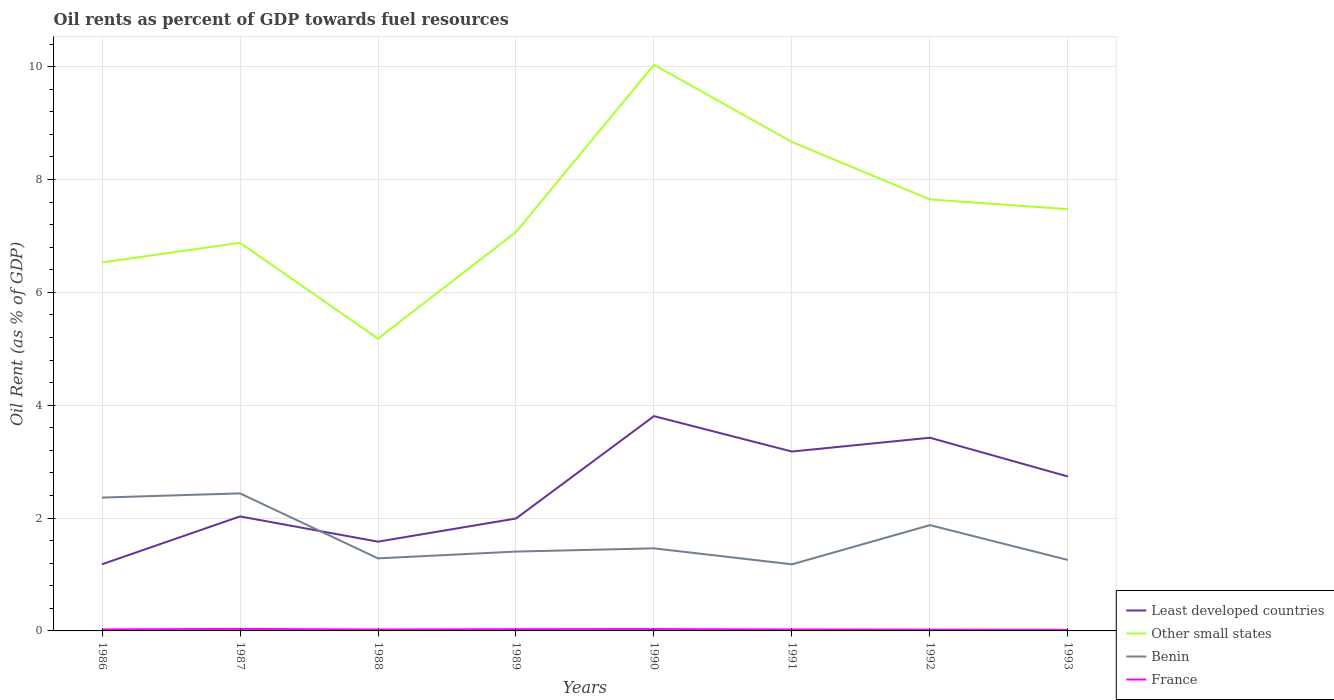How many different coloured lines are there?
Keep it short and to the point. 4. Does the line corresponding to Benin intersect with the line corresponding to France?
Give a very brief answer. No. Across all years, what is the maximum oil rent in France?
Give a very brief answer. 0.02. What is the total oil rent in Least developed countries in the graph?
Make the answer very short. -0.71. What is the difference between the highest and the second highest oil rent in Other small states?
Your answer should be very brief. 4.85. Does the graph contain any zero values?
Offer a terse response. No. How are the legend labels stacked?
Offer a terse response. Vertical. What is the title of the graph?
Offer a very short reply. Oil rents as percent of GDP towards fuel resources. What is the label or title of the Y-axis?
Your answer should be compact. Oil Rent (as % of GDP). What is the Oil Rent (as % of GDP) in Least developed countries in 1986?
Keep it short and to the point. 1.18. What is the Oil Rent (as % of GDP) in Other small states in 1986?
Offer a very short reply. 6.53. What is the Oil Rent (as % of GDP) of Benin in 1986?
Your answer should be compact. 2.36. What is the Oil Rent (as % of GDP) of France in 1986?
Make the answer very short. 0.03. What is the Oil Rent (as % of GDP) in Least developed countries in 1987?
Your answer should be very brief. 2.03. What is the Oil Rent (as % of GDP) of Other small states in 1987?
Make the answer very short. 6.88. What is the Oil Rent (as % of GDP) of Benin in 1987?
Make the answer very short. 2.44. What is the Oil Rent (as % of GDP) in France in 1987?
Make the answer very short. 0.04. What is the Oil Rent (as % of GDP) in Least developed countries in 1988?
Give a very brief answer. 1.58. What is the Oil Rent (as % of GDP) in Other small states in 1988?
Offer a terse response. 5.18. What is the Oil Rent (as % of GDP) of Benin in 1988?
Ensure brevity in your answer.  1.29. What is the Oil Rent (as % of GDP) of France in 1988?
Keep it short and to the point. 0.02. What is the Oil Rent (as % of GDP) of Least developed countries in 1989?
Offer a terse response. 1.99. What is the Oil Rent (as % of GDP) of Other small states in 1989?
Offer a terse response. 7.07. What is the Oil Rent (as % of GDP) of Benin in 1989?
Your answer should be very brief. 1.41. What is the Oil Rent (as % of GDP) in France in 1989?
Offer a terse response. 0.03. What is the Oil Rent (as % of GDP) of Least developed countries in 1990?
Your answer should be very brief. 3.81. What is the Oil Rent (as % of GDP) in Other small states in 1990?
Make the answer very short. 10.03. What is the Oil Rent (as % of GDP) in Benin in 1990?
Your answer should be very brief. 1.46. What is the Oil Rent (as % of GDP) of France in 1990?
Provide a succinct answer. 0.03. What is the Oil Rent (as % of GDP) in Least developed countries in 1991?
Provide a short and direct response. 3.18. What is the Oil Rent (as % of GDP) of Other small states in 1991?
Your response must be concise. 8.66. What is the Oil Rent (as % of GDP) of Benin in 1991?
Make the answer very short. 1.18. What is the Oil Rent (as % of GDP) in France in 1991?
Your answer should be compact. 0.03. What is the Oil Rent (as % of GDP) in Least developed countries in 1992?
Ensure brevity in your answer.  3.42. What is the Oil Rent (as % of GDP) in Other small states in 1992?
Offer a very short reply. 7.65. What is the Oil Rent (as % of GDP) in Benin in 1992?
Your answer should be very brief. 1.87. What is the Oil Rent (as % of GDP) of France in 1992?
Ensure brevity in your answer.  0.02. What is the Oil Rent (as % of GDP) of Least developed countries in 1993?
Your answer should be compact. 2.74. What is the Oil Rent (as % of GDP) of Other small states in 1993?
Your answer should be very brief. 7.47. What is the Oil Rent (as % of GDP) of Benin in 1993?
Ensure brevity in your answer.  1.26. What is the Oil Rent (as % of GDP) in France in 1993?
Make the answer very short. 0.02. Across all years, what is the maximum Oil Rent (as % of GDP) of Least developed countries?
Provide a short and direct response. 3.81. Across all years, what is the maximum Oil Rent (as % of GDP) of Other small states?
Your response must be concise. 10.03. Across all years, what is the maximum Oil Rent (as % of GDP) of Benin?
Give a very brief answer. 2.44. Across all years, what is the maximum Oil Rent (as % of GDP) in France?
Your response must be concise. 0.04. Across all years, what is the minimum Oil Rent (as % of GDP) of Least developed countries?
Offer a very short reply. 1.18. Across all years, what is the minimum Oil Rent (as % of GDP) of Other small states?
Offer a terse response. 5.18. Across all years, what is the minimum Oil Rent (as % of GDP) in Benin?
Your answer should be very brief. 1.18. Across all years, what is the minimum Oil Rent (as % of GDP) of France?
Offer a very short reply. 0.02. What is the total Oil Rent (as % of GDP) in Least developed countries in the graph?
Your response must be concise. 19.93. What is the total Oil Rent (as % of GDP) in Other small states in the graph?
Keep it short and to the point. 59.47. What is the total Oil Rent (as % of GDP) in Benin in the graph?
Provide a short and direct response. 13.27. What is the total Oil Rent (as % of GDP) in France in the graph?
Offer a terse response. 0.22. What is the difference between the Oil Rent (as % of GDP) in Least developed countries in 1986 and that in 1987?
Make the answer very short. -0.85. What is the difference between the Oil Rent (as % of GDP) of Other small states in 1986 and that in 1987?
Provide a succinct answer. -0.35. What is the difference between the Oil Rent (as % of GDP) in Benin in 1986 and that in 1987?
Your answer should be compact. -0.07. What is the difference between the Oil Rent (as % of GDP) in France in 1986 and that in 1987?
Offer a terse response. -0.01. What is the difference between the Oil Rent (as % of GDP) in Least developed countries in 1986 and that in 1988?
Keep it short and to the point. -0.4. What is the difference between the Oil Rent (as % of GDP) of Other small states in 1986 and that in 1988?
Provide a short and direct response. 1.35. What is the difference between the Oil Rent (as % of GDP) in Benin in 1986 and that in 1988?
Give a very brief answer. 1.08. What is the difference between the Oil Rent (as % of GDP) of France in 1986 and that in 1988?
Ensure brevity in your answer.  0. What is the difference between the Oil Rent (as % of GDP) in Least developed countries in 1986 and that in 1989?
Give a very brief answer. -0.81. What is the difference between the Oil Rent (as % of GDP) in Other small states in 1986 and that in 1989?
Give a very brief answer. -0.54. What is the difference between the Oil Rent (as % of GDP) of Benin in 1986 and that in 1989?
Your answer should be compact. 0.96. What is the difference between the Oil Rent (as % of GDP) of France in 1986 and that in 1989?
Offer a very short reply. -0. What is the difference between the Oil Rent (as % of GDP) of Least developed countries in 1986 and that in 1990?
Your answer should be compact. -2.63. What is the difference between the Oil Rent (as % of GDP) of Other small states in 1986 and that in 1990?
Give a very brief answer. -3.5. What is the difference between the Oil Rent (as % of GDP) in Benin in 1986 and that in 1990?
Your answer should be very brief. 0.9. What is the difference between the Oil Rent (as % of GDP) in France in 1986 and that in 1990?
Your answer should be compact. -0.01. What is the difference between the Oil Rent (as % of GDP) of Least developed countries in 1986 and that in 1991?
Give a very brief answer. -2. What is the difference between the Oil Rent (as % of GDP) of Other small states in 1986 and that in 1991?
Make the answer very short. -2.13. What is the difference between the Oil Rent (as % of GDP) of Benin in 1986 and that in 1991?
Keep it short and to the point. 1.18. What is the difference between the Oil Rent (as % of GDP) of France in 1986 and that in 1991?
Offer a terse response. 0. What is the difference between the Oil Rent (as % of GDP) in Least developed countries in 1986 and that in 1992?
Provide a short and direct response. -2.24. What is the difference between the Oil Rent (as % of GDP) in Other small states in 1986 and that in 1992?
Your answer should be very brief. -1.12. What is the difference between the Oil Rent (as % of GDP) in Benin in 1986 and that in 1992?
Provide a succinct answer. 0.49. What is the difference between the Oil Rent (as % of GDP) in France in 1986 and that in 1992?
Offer a very short reply. 0.01. What is the difference between the Oil Rent (as % of GDP) of Least developed countries in 1986 and that in 1993?
Make the answer very short. -1.55. What is the difference between the Oil Rent (as % of GDP) of Other small states in 1986 and that in 1993?
Ensure brevity in your answer.  -0.94. What is the difference between the Oil Rent (as % of GDP) in Benin in 1986 and that in 1993?
Offer a very short reply. 1.11. What is the difference between the Oil Rent (as % of GDP) in France in 1986 and that in 1993?
Offer a very short reply. 0.01. What is the difference between the Oil Rent (as % of GDP) in Least developed countries in 1987 and that in 1988?
Make the answer very short. 0.45. What is the difference between the Oil Rent (as % of GDP) in Other small states in 1987 and that in 1988?
Keep it short and to the point. 1.7. What is the difference between the Oil Rent (as % of GDP) in Benin in 1987 and that in 1988?
Your answer should be compact. 1.15. What is the difference between the Oil Rent (as % of GDP) in France in 1987 and that in 1988?
Make the answer very short. 0.01. What is the difference between the Oil Rent (as % of GDP) of Least developed countries in 1987 and that in 1989?
Offer a terse response. 0.04. What is the difference between the Oil Rent (as % of GDP) in Other small states in 1987 and that in 1989?
Offer a very short reply. -0.19. What is the difference between the Oil Rent (as % of GDP) in Benin in 1987 and that in 1989?
Make the answer very short. 1.03. What is the difference between the Oil Rent (as % of GDP) of France in 1987 and that in 1989?
Give a very brief answer. 0. What is the difference between the Oil Rent (as % of GDP) of Least developed countries in 1987 and that in 1990?
Keep it short and to the point. -1.78. What is the difference between the Oil Rent (as % of GDP) of Other small states in 1987 and that in 1990?
Give a very brief answer. -3.15. What is the difference between the Oil Rent (as % of GDP) of Benin in 1987 and that in 1990?
Offer a terse response. 0.97. What is the difference between the Oil Rent (as % of GDP) of France in 1987 and that in 1990?
Keep it short and to the point. 0. What is the difference between the Oil Rent (as % of GDP) in Least developed countries in 1987 and that in 1991?
Your response must be concise. -1.15. What is the difference between the Oil Rent (as % of GDP) in Other small states in 1987 and that in 1991?
Provide a succinct answer. -1.79. What is the difference between the Oil Rent (as % of GDP) in Benin in 1987 and that in 1991?
Provide a short and direct response. 1.26. What is the difference between the Oil Rent (as % of GDP) in France in 1987 and that in 1991?
Keep it short and to the point. 0.01. What is the difference between the Oil Rent (as % of GDP) of Least developed countries in 1987 and that in 1992?
Offer a very short reply. -1.39. What is the difference between the Oil Rent (as % of GDP) in Other small states in 1987 and that in 1992?
Your answer should be compact. -0.77. What is the difference between the Oil Rent (as % of GDP) of Benin in 1987 and that in 1992?
Offer a terse response. 0.56. What is the difference between the Oil Rent (as % of GDP) of France in 1987 and that in 1992?
Give a very brief answer. 0.01. What is the difference between the Oil Rent (as % of GDP) of Least developed countries in 1987 and that in 1993?
Keep it short and to the point. -0.71. What is the difference between the Oil Rent (as % of GDP) in Other small states in 1987 and that in 1993?
Your response must be concise. -0.6. What is the difference between the Oil Rent (as % of GDP) in Benin in 1987 and that in 1993?
Offer a terse response. 1.18. What is the difference between the Oil Rent (as % of GDP) of France in 1987 and that in 1993?
Give a very brief answer. 0.02. What is the difference between the Oil Rent (as % of GDP) of Least developed countries in 1988 and that in 1989?
Provide a succinct answer. -0.41. What is the difference between the Oil Rent (as % of GDP) in Other small states in 1988 and that in 1989?
Provide a succinct answer. -1.89. What is the difference between the Oil Rent (as % of GDP) in Benin in 1988 and that in 1989?
Ensure brevity in your answer.  -0.12. What is the difference between the Oil Rent (as % of GDP) in France in 1988 and that in 1989?
Offer a very short reply. -0.01. What is the difference between the Oil Rent (as % of GDP) in Least developed countries in 1988 and that in 1990?
Ensure brevity in your answer.  -2.22. What is the difference between the Oil Rent (as % of GDP) in Other small states in 1988 and that in 1990?
Your response must be concise. -4.85. What is the difference between the Oil Rent (as % of GDP) in Benin in 1988 and that in 1990?
Provide a succinct answer. -0.18. What is the difference between the Oil Rent (as % of GDP) of France in 1988 and that in 1990?
Your answer should be compact. -0.01. What is the difference between the Oil Rent (as % of GDP) of Least developed countries in 1988 and that in 1991?
Keep it short and to the point. -1.6. What is the difference between the Oil Rent (as % of GDP) of Other small states in 1988 and that in 1991?
Offer a terse response. -3.48. What is the difference between the Oil Rent (as % of GDP) of Benin in 1988 and that in 1991?
Your answer should be compact. 0.11. What is the difference between the Oil Rent (as % of GDP) in France in 1988 and that in 1991?
Your response must be concise. -0. What is the difference between the Oil Rent (as % of GDP) of Least developed countries in 1988 and that in 1992?
Your response must be concise. -1.84. What is the difference between the Oil Rent (as % of GDP) of Other small states in 1988 and that in 1992?
Your answer should be compact. -2.47. What is the difference between the Oil Rent (as % of GDP) of Benin in 1988 and that in 1992?
Provide a succinct answer. -0.59. What is the difference between the Oil Rent (as % of GDP) of France in 1988 and that in 1992?
Offer a terse response. 0. What is the difference between the Oil Rent (as % of GDP) of Least developed countries in 1988 and that in 1993?
Offer a very short reply. -1.15. What is the difference between the Oil Rent (as % of GDP) in Other small states in 1988 and that in 1993?
Offer a terse response. -2.29. What is the difference between the Oil Rent (as % of GDP) of Benin in 1988 and that in 1993?
Make the answer very short. 0.03. What is the difference between the Oil Rent (as % of GDP) in France in 1988 and that in 1993?
Offer a terse response. 0.01. What is the difference between the Oil Rent (as % of GDP) in Least developed countries in 1989 and that in 1990?
Your answer should be very brief. -1.81. What is the difference between the Oil Rent (as % of GDP) of Other small states in 1989 and that in 1990?
Make the answer very short. -2.96. What is the difference between the Oil Rent (as % of GDP) in Benin in 1989 and that in 1990?
Your response must be concise. -0.06. What is the difference between the Oil Rent (as % of GDP) in France in 1989 and that in 1990?
Make the answer very short. -0. What is the difference between the Oil Rent (as % of GDP) of Least developed countries in 1989 and that in 1991?
Keep it short and to the point. -1.19. What is the difference between the Oil Rent (as % of GDP) in Other small states in 1989 and that in 1991?
Your answer should be compact. -1.59. What is the difference between the Oil Rent (as % of GDP) of Benin in 1989 and that in 1991?
Offer a terse response. 0.23. What is the difference between the Oil Rent (as % of GDP) in France in 1989 and that in 1991?
Your answer should be compact. 0.01. What is the difference between the Oil Rent (as % of GDP) in Least developed countries in 1989 and that in 1992?
Your response must be concise. -1.43. What is the difference between the Oil Rent (as % of GDP) in Other small states in 1989 and that in 1992?
Offer a very short reply. -0.58. What is the difference between the Oil Rent (as % of GDP) in Benin in 1989 and that in 1992?
Your answer should be compact. -0.47. What is the difference between the Oil Rent (as % of GDP) of France in 1989 and that in 1992?
Your answer should be compact. 0.01. What is the difference between the Oil Rent (as % of GDP) of Least developed countries in 1989 and that in 1993?
Offer a very short reply. -0.74. What is the difference between the Oil Rent (as % of GDP) in Other small states in 1989 and that in 1993?
Offer a terse response. -0.4. What is the difference between the Oil Rent (as % of GDP) of Benin in 1989 and that in 1993?
Offer a terse response. 0.15. What is the difference between the Oil Rent (as % of GDP) in France in 1989 and that in 1993?
Keep it short and to the point. 0.01. What is the difference between the Oil Rent (as % of GDP) in Least developed countries in 1990 and that in 1991?
Your answer should be compact. 0.63. What is the difference between the Oil Rent (as % of GDP) of Other small states in 1990 and that in 1991?
Offer a terse response. 1.37. What is the difference between the Oil Rent (as % of GDP) in Benin in 1990 and that in 1991?
Ensure brevity in your answer.  0.28. What is the difference between the Oil Rent (as % of GDP) in France in 1990 and that in 1991?
Provide a succinct answer. 0.01. What is the difference between the Oil Rent (as % of GDP) in Least developed countries in 1990 and that in 1992?
Offer a very short reply. 0.38. What is the difference between the Oil Rent (as % of GDP) of Other small states in 1990 and that in 1992?
Ensure brevity in your answer.  2.39. What is the difference between the Oil Rent (as % of GDP) in Benin in 1990 and that in 1992?
Your answer should be compact. -0.41. What is the difference between the Oil Rent (as % of GDP) of France in 1990 and that in 1992?
Keep it short and to the point. 0.01. What is the difference between the Oil Rent (as % of GDP) of Least developed countries in 1990 and that in 1993?
Make the answer very short. 1.07. What is the difference between the Oil Rent (as % of GDP) in Other small states in 1990 and that in 1993?
Give a very brief answer. 2.56. What is the difference between the Oil Rent (as % of GDP) of Benin in 1990 and that in 1993?
Provide a succinct answer. 0.21. What is the difference between the Oil Rent (as % of GDP) of France in 1990 and that in 1993?
Make the answer very short. 0.01. What is the difference between the Oil Rent (as % of GDP) of Least developed countries in 1991 and that in 1992?
Make the answer very short. -0.24. What is the difference between the Oil Rent (as % of GDP) of Other small states in 1991 and that in 1992?
Provide a short and direct response. 1.02. What is the difference between the Oil Rent (as % of GDP) of Benin in 1991 and that in 1992?
Your answer should be very brief. -0.69. What is the difference between the Oil Rent (as % of GDP) in France in 1991 and that in 1992?
Make the answer very short. 0. What is the difference between the Oil Rent (as % of GDP) in Least developed countries in 1991 and that in 1993?
Provide a succinct answer. 0.44. What is the difference between the Oil Rent (as % of GDP) of Other small states in 1991 and that in 1993?
Provide a succinct answer. 1.19. What is the difference between the Oil Rent (as % of GDP) of Benin in 1991 and that in 1993?
Your response must be concise. -0.08. What is the difference between the Oil Rent (as % of GDP) of France in 1991 and that in 1993?
Keep it short and to the point. 0.01. What is the difference between the Oil Rent (as % of GDP) of Least developed countries in 1992 and that in 1993?
Provide a succinct answer. 0.69. What is the difference between the Oil Rent (as % of GDP) of Other small states in 1992 and that in 1993?
Your response must be concise. 0.17. What is the difference between the Oil Rent (as % of GDP) of Benin in 1992 and that in 1993?
Your answer should be compact. 0.62. What is the difference between the Oil Rent (as % of GDP) in France in 1992 and that in 1993?
Make the answer very short. 0. What is the difference between the Oil Rent (as % of GDP) of Least developed countries in 1986 and the Oil Rent (as % of GDP) of Other small states in 1987?
Offer a very short reply. -5.7. What is the difference between the Oil Rent (as % of GDP) of Least developed countries in 1986 and the Oil Rent (as % of GDP) of Benin in 1987?
Make the answer very short. -1.26. What is the difference between the Oil Rent (as % of GDP) in Least developed countries in 1986 and the Oil Rent (as % of GDP) in France in 1987?
Ensure brevity in your answer.  1.15. What is the difference between the Oil Rent (as % of GDP) of Other small states in 1986 and the Oil Rent (as % of GDP) of Benin in 1987?
Your answer should be compact. 4.09. What is the difference between the Oil Rent (as % of GDP) of Other small states in 1986 and the Oil Rent (as % of GDP) of France in 1987?
Offer a very short reply. 6.49. What is the difference between the Oil Rent (as % of GDP) in Benin in 1986 and the Oil Rent (as % of GDP) in France in 1987?
Offer a terse response. 2.33. What is the difference between the Oil Rent (as % of GDP) in Least developed countries in 1986 and the Oil Rent (as % of GDP) in Other small states in 1988?
Make the answer very short. -4. What is the difference between the Oil Rent (as % of GDP) in Least developed countries in 1986 and the Oil Rent (as % of GDP) in Benin in 1988?
Your answer should be very brief. -0.1. What is the difference between the Oil Rent (as % of GDP) in Least developed countries in 1986 and the Oil Rent (as % of GDP) in France in 1988?
Offer a terse response. 1.16. What is the difference between the Oil Rent (as % of GDP) of Other small states in 1986 and the Oil Rent (as % of GDP) of Benin in 1988?
Provide a succinct answer. 5.24. What is the difference between the Oil Rent (as % of GDP) in Other small states in 1986 and the Oil Rent (as % of GDP) in France in 1988?
Your response must be concise. 6.5. What is the difference between the Oil Rent (as % of GDP) in Benin in 1986 and the Oil Rent (as % of GDP) in France in 1988?
Give a very brief answer. 2.34. What is the difference between the Oil Rent (as % of GDP) in Least developed countries in 1986 and the Oil Rent (as % of GDP) in Other small states in 1989?
Your response must be concise. -5.89. What is the difference between the Oil Rent (as % of GDP) in Least developed countries in 1986 and the Oil Rent (as % of GDP) in Benin in 1989?
Offer a terse response. -0.23. What is the difference between the Oil Rent (as % of GDP) of Least developed countries in 1986 and the Oil Rent (as % of GDP) of France in 1989?
Your answer should be compact. 1.15. What is the difference between the Oil Rent (as % of GDP) of Other small states in 1986 and the Oil Rent (as % of GDP) of Benin in 1989?
Offer a terse response. 5.12. What is the difference between the Oil Rent (as % of GDP) in Other small states in 1986 and the Oil Rent (as % of GDP) in France in 1989?
Provide a short and direct response. 6.5. What is the difference between the Oil Rent (as % of GDP) of Benin in 1986 and the Oil Rent (as % of GDP) of France in 1989?
Offer a terse response. 2.33. What is the difference between the Oil Rent (as % of GDP) of Least developed countries in 1986 and the Oil Rent (as % of GDP) of Other small states in 1990?
Your answer should be compact. -8.85. What is the difference between the Oil Rent (as % of GDP) of Least developed countries in 1986 and the Oil Rent (as % of GDP) of Benin in 1990?
Your response must be concise. -0.28. What is the difference between the Oil Rent (as % of GDP) in Least developed countries in 1986 and the Oil Rent (as % of GDP) in France in 1990?
Keep it short and to the point. 1.15. What is the difference between the Oil Rent (as % of GDP) of Other small states in 1986 and the Oil Rent (as % of GDP) of Benin in 1990?
Offer a very short reply. 5.07. What is the difference between the Oil Rent (as % of GDP) in Other small states in 1986 and the Oil Rent (as % of GDP) in France in 1990?
Offer a very short reply. 6.5. What is the difference between the Oil Rent (as % of GDP) in Benin in 1986 and the Oil Rent (as % of GDP) in France in 1990?
Your answer should be compact. 2.33. What is the difference between the Oil Rent (as % of GDP) in Least developed countries in 1986 and the Oil Rent (as % of GDP) in Other small states in 1991?
Make the answer very short. -7.48. What is the difference between the Oil Rent (as % of GDP) of Least developed countries in 1986 and the Oil Rent (as % of GDP) of Benin in 1991?
Provide a succinct answer. 0. What is the difference between the Oil Rent (as % of GDP) in Least developed countries in 1986 and the Oil Rent (as % of GDP) in France in 1991?
Give a very brief answer. 1.16. What is the difference between the Oil Rent (as % of GDP) in Other small states in 1986 and the Oil Rent (as % of GDP) in Benin in 1991?
Provide a short and direct response. 5.35. What is the difference between the Oil Rent (as % of GDP) of Other small states in 1986 and the Oil Rent (as % of GDP) of France in 1991?
Keep it short and to the point. 6.5. What is the difference between the Oil Rent (as % of GDP) in Benin in 1986 and the Oil Rent (as % of GDP) in France in 1991?
Your answer should be very brief. 2.34. What is the difference between the Oil Rent (as % of GDP) of Least developed countries in 1986 and the Oil Rent (as % of GDP) of Other small states in 1992?
Offer a terse response. -6.46. What is the difference between the Oil Rent (as % of GDP) of Least developed countries in 1986 and the Oil Rent (as % of GDP) of Benin in 1992?
Your response must be concise. -0.69. What is the difference between the Oil Rent (as % of GDP) in Least developed countries in 1986 and the Oil Rent (as % of GDP) in France in 1992?
Your answer should be compact. 1.16. What is the difference between the Oil Rent (as % of GDP) in Other small states in 1986 and the Oil Rent (as % of GDP) in Benin in 1992?
Your response must be concise. 4.65. What is the difference between the Oil Rent (as % of GDP) in Other small states in 1986 and the Oil Rent (as % of GDP) in France in 1992?
Provide a succinct answer. 6.51. What is the difference between the Oil Rent (as % of GDP) in Benin in 1986 and the Oil Rent (as % of GDP) in France in 1992?
Ensure brevity in your answer.  2.34. What is the difference between the Oil Rent (as % of GDP) in Least developed countries in 1986 and the Oil Rent (as % of GDP) in Other small states in 1993?
Make the answer very short. -6.29. What is the difference between the Oil Rent (as % of GDP) in Least developed countries in 1986 and the Oil Rent (as % of GDP) in Benin in 1993?
Your response must be concise. -0.08. What is the difference between the Oil Rent (as % of GDP) of Least developed countries in 1986 and the Oil Rent (as % of GDP) of France in 1993?
Keep it short and to the point. 1.16. What is the difference between the Oil Rent (as % of GDP) of Other small states in 1986 and the Oil Rent (as % of GDP) of Benin in 1993?
Give a very brief answer. 5.27. What is the difference between the Oil Rent (as % of GDP) of Other small states in 1986 and the Oil Rent (as % of GDP) of France in 1993?
Provide a short and direct response. 6.51. What is the difference between the Oil Rent (as % of GDP) of Benin in 1986 and the Oil Rent (as % of GDP) of France in 1993?
Keep it short and to the point. 2.34. What is the difference between the Oil Rent (as % of GDP) of Least developed countries in 1987 and the Oil Rent (as % of GDP) of Other small states in 1988?
Give a very brief answer. -3.15. What is the difference between the Oil Rent (as % of GDP) of Least developed countries in 1987 and the Oil Rent (as % of GDP) of Benin in 1988?
Ensure brevity in your answer.  0.74. What is the difference between the Oil Rent (as % of GDP) of Least developed countries in 1987 and the Oil Rent (as % of GDP) of France in 1988?
Make the answer very short. 2. What is the difference between the Oil Rent (as % of GDP) in Other small states in 1987 and the Oil Rent (as % of GDP) in Benin in 1988?
Give a very brief answer. 5.59. What is the difference between the Oil Rent (as % of GDP) of Other small states in 1987 and the Oil Rent (as % of GDP) of France in 1988?
Your answer should be compact. 6.85. What is the difference between the Oil Rent (as % of GDP) of Benin in 1987 and the Oil Rent (as % of GDP) of France in 1988?
Your answer should be compact. 2.41. What is the difference between the Oil Rent (as % of GDP) of Least developed countries in 1987 and the Oil Rent (as % of GDP) of Other small states in 1989?
Provide a succinct answer. -5.04. What is the difference between the Oil Rent (as % of GDP) in Least developed countries in 1987 and the Oil Rent (as % of GDP) in Benin in 1989?
Provide a succinct answer. 0.62. What is the difference between the Oil Rent (as % of GDP) of Least developed countries in 1987 and the Oil Rent (as % of GDP) of France in 1989?
Offer a very short reply. 2. What is the difference between the Oil Rent (as % of GDP) in Other small states in 1987 and the Oil Rent (as % of GDP) in Benin in 1989?
Keep it short and to the point. 5.47. What is the difference between the Oil Rent (as % of GDP) in Other small states in 1987 and the Oil Rent (as % of GDP) in France in 1989?
Make the answer very short. 6.85. What is the difference between the Oil Rent (as % of GDP) of Benin in 1987 and the Oil Rent (as % of GDP) of France in 1989?
Provide a short and direct response. 2.41. What is the difference between the Oil Rent (as % of GDP) of Least developed countries in 1987 and the Oil Rent (as % of GDP) of Other small states in 1990?
Make the answer very short. -8. What is the difference between the Oil Rent (as % of GDP) of Least developed countries in 1987 and the Oil Rent (as % of GDP) of Benin in 1990?
Offer a terse response. 0.57. What is the difference between the Oil Rent (as % of GDP) of Least developed countries in 1987 and the Oil Rent (as % of GDP) of France in 1990?
Offer a terse response. 2. What is the difference between the Oil Rent (as % of GDP) of Other small states in 1987 and the Oil Rent (as % of GDP) of Benin in 1990?
Your response must be concise. 5.41. What is the difference between the Oil Rent (as % of GDP) in Other small states in 1987 and the Oil Rent (as % of GDP) in France in 1990?
Offer a terse response. 6.85. What is the difference between the Oil Rent (as % of GDP) of Benin in 1987 and the Oil Rent (as % of GDP) of France in 1990?
Provide a short and direct response. 2.4. What is the difference between the Oil Rent (as % of GDP) in Least developed countries in 1987 and the Oil Rent (as % of GDP) in Other small states in 1991?
Provide a short and direct response. -6.63. What is the difference between the Oil Rent (as % of GDP) of Least developed countries in 1987 and the Oil Rent (as % of GDP) of Benin in 1991?
Your response must be concise. 0.85. What is the difference between the Oil Rent (as % of GDP) of Least developed countries in 1987 and the Oil Rent (as % of GDP) of France in 1991?
Offer a very short reply. 2. What is the difference between the Oil Rent (as % of GDP) of Other small states in 1987 and the Oil Rent (as % of GDP) of Benin in 1991?
Provide a succinct answer. 5.7. What is the difference between the Oil Rent (as % of GDP) of Other small states in 1987 and the Oil Rent (as % of GDP) of France in 1991?
Your response must be concise. 6.85. What is the difference between the Oil Rent (as % of GDP) in Benin in 1987 and the Oil Rent (as % of GDP) in France in 1991?
Provide a short and direct response. 2.41. What is the difference between the Oil Rent (as % of GDP) of Least developed countries in 1987 and the Oil Rent (as % of GDP) of Other small states in 1992?
Your response must be concise. -5.62. What is the difference between the Oil Rent (as % of GDP) of Least developed countries in 1987 and the Oil Rent (as % of GDP) of Benin in 1992?
Keep it short and to the point. 0.15. What is the difference between the Oil Rent (as % of GDP) of Least developed countries in 1987 and the Oil Rent (as % of GDP) of France in 1992?
Your response must be concise. 2.01. What is the difference between the Oil Rent (as % of GDP) of Other small states in 1987 and the Oil Rent (as % of GDP) of Benin in 1992?
Provide a short and direct response. 5. What is the difference between the Oil Rent (as % of GDP) of Other small states in 1987 and the Oil Rent (as % of GDP) of France in 1992?
Make the answer very short. 6.86. What is the difference between the Oil Rent (as % of GDP) of Benin in 1987 and the Oil Rent (as % of GDP) of France in 1992?
Make the answer very short. 2.42. What is the difference between the Oil Rent (as % of GDP) in Least developed countries in 1987 and the Oil Rent (as % of GDP) in Other small states in 1993?
Your answer should be compact. -5.44. What is the difference between the Oil Rent (as % of GDP) of Least developed countries in 1987 and the Oil Rent (as % of GDP) of Benin in 1993?
Give a very brief answer. 0.77. What is the difference between the Oil Rent (as % of GDP) in Least developed countries in 1987 and the Oil Rent (as % of GDP) in France in 1993?
Keep it short and to the point. 2.01. What is the difference between the Oil Rent (as % of GDP) of Other small states in 1987 and the Oil Rent (as % of GDP) of Benin in 1993?
Make the answer very short. 5.62. What is the difference between the Oil Rent (as % of GDP) in Other small states in 1987 and the Oil Rent (as % of GDP) in France in 1993?
Your response must be concise. 6.86. What is the difference between the Oil Rent (as % of GDP) in Benin in 1987 and the Oil Rent (as % of GDP) in France in 1993?
Offer a terse response. 2.42. What is the difference between the Oil Rent (as % of GDP) of Least developed countries in 1988 and the Oil Rent (as % of GDP) of Other small states in 1989?
Give a very brief answer. -5.49. What is the difference between the Oil Rent (as % of GDP) of Least developed countries in 1988 and the Oil Rent (as % of GDP) of Benin in 1989?
Your answer should be compact. 0.18. What is the difference between the Oil Rent (as % of GDP) of Least developed countries in 1988 and the Oil Rent (as % of GDP) of France in 1989?
Provide a short and direct response. 1.55. What is the difference between the Oil Rent (as % of GDP) in Other small states in 1988 and the Oil Rent (as % of GDP) in Benin in 1989?
Your answer should be compact. 3.77. What is the difference between the Oil Rent (as % of GDP) in Other small states in 1988 and the Oil Rent (as % of GDP) in France in 1989?
Ensure brevity in your answer.  5.15. What is the difference between the Oil Rent (as % of GDP) of Benin in 1988 and the Oil Rent (as % of GDP) of France in 1989?
Keep it short and to the point. 1.25. What is the difference between the Oil Rent (as % of GDP) in Least developed countries in 1988 and the Oil Rent (as % of GDP) in Other small states in 1990?
Keep it short and to the point. -8.45. What is the difference between the Oil Rent (as % of GDP) in Least developed countries in 1988 and the Oil Rent (as % of GDP) in Benin in 1990?
Provide a short and direct response. 0.12. What is the difference between the Oil Rent (as % of GDP) in Least developed countries in 1988 and the Oil Rent (as % of GDP) in France in 1990?
Make the answer very short. 1.55. What is the difference between the Oil Rent (as % of GDP) in Other small states in 1988 and the Oil Rent (as % of GDP) in Benin in 1990?
Ensure brevity in your answer.  3.72. What is the difference between the Oil Rent (as % of GDP) of Other small states in 1988 and the Oil Rent (as % of GDP) of France in 1990?
Provide a short and direct response. 5.15. What is the difference between the Oil Rent (as % of GDP) of Benin in 1988 and the Oil Rent (as % of GDP) of France in 1990?
Your answer should be compact. 1.25. What is the difference between the Oil Rent (as % of GDP) in Least developed countries in 1988 and the Oil Rent (as % of GDP) in Other small states in 1991?
Your answer should be very brief. -7.08. What is the difference between the Oil Rent (as % of GDP) of Least developed countries in 1988 and the Oil Rent (as % of GDP) of Benin in 1991?
Give a very brief answer. 0.4. What is the difference between the Oil Rent (as % of GDP) of Least developed countries in 1988 and the Oil Rent (as % of GDP) of France in 1991?
Provide a succinct answer. 1.56. What is the difference between the Oil Rent (as % of GDP) of Other small states in 1988 and the Oil Rent (as % of GDP) of Benin in 1991?
Provide a succinct answer. 4. What is the difference between the Oil Rent (as % of GDP) in Other small states in 1988 and the Oil Rent (as % of GDP) in France in 1991?
Make the answer very short. 5.15. What is the difference between the Oil Rent (as % of GDP) in Benin in 1988 and the Oil Rent (as % of GDP) in France in 1991?
Provide a short and direct response. 1.26. What is the difference between the Oil Rent (as % of GDP) of Least developed countries in 1988 and the Oil Rent (as % of GDP) of Other small states in 1992?
Your response must be concise. -6.06. What is the difference between the Oil Rent (as % of GDP) of Least developed countries in 1988 and the Oil Rent (as % of GDP) of Benin in 1992?
Your answer should be very brief. -0.29. What is the difference between the Oil Rent (as % of GDP) in Least developed countries in 1988 and the Oil Rent (as % of GDP) in France in 1992?
Offer a very short reply. 1.56. What is the difference between the Oil Rent (as % of GDP) of Other small states in 1988 and the Oil Rent (as % of GDP) of Benin in 1992?
Your response must be concise. 3.3. What is the difference between the Oil Rent (as % of GDP) in Other small states in 1988 and the Oil Rent (as % of GDP) in France in 1992?
Your response must be concise. 5.16. What is the difference between the Oil Rent (as % of GDP) in Benin in 1988 and the Oil Rent (as % of GDP) in France in 1992?
Ensure brevity in your answer.  1.26. What is the difference between the Oil Rent (as % of GDP) of Least developed countries in 1988 and the Oil Rent (as % of GDP) of Other small states in 1993?
Offer a terse response. -5.89. What is the difference between the Oil Rent (as % of GDP) of Least developed countries in 1988 and the Oil Rent (as % of GDP) of Benin in 1993?
Your answer should be very brief. 0.33. What is the difference between the Oil Rent (as % of GDP) in Least developed countries in 1988 and the Oil Rent (as % of GDP) in France in 1993?
Your answer should be compact. 1.56. What is the difference between the Oil Rent (as % of GDP) of Other small states in 1988 and the Oil Rent (as % of GDP) of Benin in 1993?
Offer a terse response. 3.92. What is the difference between the Oil Rent (as % of GDP) of Other small states in 1988 and the Oil Rent (as % of GDP) of France in 1993?
Provide a succinct answer. 5.16. What is the difference between the Oil Rent (as % of GDP) in Benin in 1988 and the Oil Rent (as % of GDP) in France in 1993?
Give a very brief answer. 1.27. What is the difference between the Oil Rent (as % of GDP) in Least developed countries in 1989 and the Oil Rent (as % of GDP) in Other small states in 1990?
Your answer should be very brief. -8.04. What is the difference between the Oil Rent (as % of GDP) in Least developed countries in 1989 and the Oil Rent (as % of GDP) in Benin in 1990?
Offer a terse response. 0.53. What is the difference between the Oil Rent (as % of GDP) of Least developed countries in 1989 and the Oil Rent (as % of GDP) of France in 1990?
Give a very brief answer. 1.96. What is the difference between the Oil Rent (as % of GDP) in Other small states in 1989 and the Oil Rent (as % of GDP) in Benin in 1990?
Offer a very short reply. 5.61. What is the difference between the Oil Rent (as % of GDP) in Other small states in 1989 and the Oil Rent (as % of GDP) in France in 1990?
Keep it short and to the point. 7.04. What is the difference between the Oil Rent (as % of GDP) of Benin in 1989 and the Oil Rent (as % of GDP) of France in 1990?
Ensure brevity in your answer.  1.37. What is the difference between the Oil Rent (as % of GDP) of Least developed countries in 1989 and the Oil Rent (as % of GDP) of Other small states in 1991?
Offer a very short reply. -6.67. What is the difference between the Oil Rent (as % of GDP) in Least developed countries in 1989 and the Oil Rent (as % of GDP) in Benin in 1991?
Keep it short and to the point. 0.81. What is the difference between the Oil Rent (as % of GDP) of Least developed countries in 1989 and the Oil Rent (as % of GDP) of France in 1991?
Offer a terse response. 1.97. What is the difference between the Oil Rent (as % of GDP) in Other small states in 1989 and the Oil Rent (as % of GDP) in Benin in 1991?
Keep it short and to the point. 5.89. What is the difference between the Oil Rent (as % of GDP) of Other small states in 1989 and the Oil Rent (as % of GDP) of France in 1991?
Give a very brief answer. 7.04. What is the difference between the Oil Rent (as % of GDP) in Benin in 1989 and the Oil Rent (as % of GDP) in France in 1991?
Make the answer very short. 1.38. What is the difference between the Oil Rent (as % of GDP) of Least developed countries in 1989 and the Oil Rent (as % of GDP) of Other small states in 1992?
Provide a short and direct response. -5.65. What is the difference between the Oil Rent (as % of GDP) of Least developed countries in 1989 and the Oil Rent (as % of GDP) of Benin in 1992?
Offer a very short reply. 0.12. What is the difference between the Oil Rent (as % of GDP) of Least developed countries in 1989 and the Oil Rent (as % of GDP) of France in 1992?
Make the answer very short. 1.97. What is the difference between the Oil Rent (as % of GDP) in Other small states in 1989 and the Oil Rent (as % of GDP) in Benin in 1992?
Offer a terse response. 5.19. What is the difference between the Oil Rent (as % of GDP) of Other small states in 1989 and the Oil Rent (as % of GDP) of France in 1992?
Make the answer very short. 7.05. What is the difference between the Oil Rent (as % of GDP) of Benin in 1989 and the Oil Rent (as % of GDP) of France in 1992?
Offer a very short reply. 1.38. What is the difference between the Oil Rent (as % of GDP) of Least developed countries in 1989 and the Oil Rent (as % of GDP) of Other small states in 1993?
Your answer should be very brief. -5.48. What is the difference between the Oil Rent (as % of GDP) of Least developed countries in 1989 and the Oil Rent (as % of GDP) of Benin in 1993?
Provide a succinct answer. 0.74. What is the difference between the Oil Rent (as % of GDP) of Least developed countries in 1989 and the Oil Rent (as % of GDP) of France in 1993?
Provide a succinct answer. 1.97. What is the difference between the Oil Rent (as % of GDP) in Other small states in 1989 and the Oil Rent (as % of GDP) in Benin in 1993?
Offer a very short reply. 5.81. What is the difference between the Oil Rent (as % of GDP) in Other small states in 1989 and the Oil Rent (as % of GDP) in France in 1993?
Keep it short and to the point. 7.05. What is the difference between the Oil Rent (as % of GDP) of Benin in 1989 and the Oil Rent (as % of GDP) of France in 1993?
Make the answer very short. 1.39. What is the difference between the Oil Rent (as % of GDP) of Least developed countries in 1990 and the Oil Rent (as % of GDP) of Other small states in 1991?
Provide a short and direct response. -4.86. What is the difference between the Oil Rent (as % of GDP) of Least developed countries in 1990 and the Oil Rent (as % of GDP) of Benin in 1991?
Make the answer very short. 2.63. What is the difference between the Oil Rent (as % of GDP) of Least developed countries in 1990 and the Oil Rent (as % of GDP) of France in 1991?
Give a very brief answer. 3.78. What is the difference between the Oil Rent (as % of GDP) in Other small states in 1990 and the Oil Rent (as % of GDP) in Benin in 1991?
Provide a short and direct response. 8.85. What is the difference between the Oil Rent (as % of GDP) of Other small states in 1990 and the Oil Rent (as % of GDP) of France in 1991?
Your answer should be very brief. 10.01. What is the difference between the Oil Rent (as % of GDP) in Benin in 1990 and the Oil Rent (as % of GDP) in France in 1991?
Offer a terse response. 1.44. What is the difference between the Oil Rent (as % of GDP) in Least developed countries in 1990 and the Oil Rent (as % of GDP) in Other small states in 1992?
Give a very brief answer. -3.84. What is the difference between the Oil Rent (as % of GDP) of Least developed countries in 1990 and the Oil Rent (as % of GDP) of Benin in 1992?
Ensure brevity in your answer.  1.93. What is the difference between the Oil Rent (as % of GDP) in Least developed countries in 1990 and the Oil Rent (as % of GDP) in France in 1992?
Make the answer very short. 3.78. What is the difference between the Oil Rent (as % of GDP) of Other small states in 1990 and the Oil Rent (as % of GDP) of Benin in 1992?
Make the answer very short. 8.16. What is the difference between the Oil Rent (as % of GDP) of Other small states in 1990 and the Oil Rent (as % of GDP) of France in 1992?
Provide a short and direct response. 10.01. What is the difference between the Oil Rent (as % of GDP) in Benin in 1990 and the Oil Rent (as % of GDP) in France in 1992?
Ensure brevity in your answer.  1.44. What is the difference between the Oil Rent (as % of GDP) in Least developed countries in 1990 and the Oil Rent (as % of GDP) in Other small states in 1993?
Offer a very short reply. -3.67. What is the difference between the Oil Rent (as % of GDP) in Least developed countries in 1990 and the Oil Rent (as % of GDP) in Benin in 1993?
Provide a succinct answer. 2.55. What is the difference between the Oil Rent (as % of GDP) of Least developed countries in 1990 and the Oil Rent (as % of GDP) of France in 1993?
Your answer should be very brief. 3.79. What is the difference between the Oil Rent (as % of GDP) of Other small states in 1990 and the Oil Rent (as % of GDP) of Benin in 1993?
Offer a terse response. 8.77. What is the difference between the Oil Rent (as % of GDP) of Other small states in 1990 and the Oil Rent (as % of GDP) of France in 1993?
Provide a succinct answer. 10.01. What is the difference between the Oil Rent (as % of GDP) in Benin in 1990 and the Oil Rent (as % of GDP) in France in 1993?
Your response must be concise. 1.44. What is the difference between the Oil Rent (as % of GDP) of Least developed countries in 1991 and the Oil Rent (as % of GDP) of Other small states in 1992?
Offer a terse response. -4.47. What is the difference between the Oil Rent (as % of GDP) in Least developed countries in 1991 and the Oil Rent (as % of GDP) in Benin in 1992?
Your answer should be very brief. 1.3. What is the difference between the Oil Rent (as % of GDP) of Least developed countries in 1991 and the Oil Rent (as % of GDP) of France in 1992?
Provide a succinct answer. 3.16. What is the difference between the Oil Rent (as % of GDP) of Other small states in 1991 and the Oil Rent (as % of GDP) of Benin in 1992?
Offer a terse response. 6.79. What is the difference between the Oil Rent (as % of GDP) in Other small states in 1991 and the Oil Rent (as % of GDP) in France in 1992?
Offer a very short reply. 8.64. What is the difference between the Oil Rent (as % of GDP) of Benin in 1991 and the Oil Rent (as % of GDP) of France in 1992?
Offer a very short reply. 1.16. What is the difference between the Oil Rent (as % of GDP) in Least developed countries in 1991 and the Oil Rent (as % of GDP) in Other small states in 1993?
Your answer should be compact. -4.29. What is the difference between the Oil Rent (as % of GDP) of Least developed countries in 1991 and the Oil Rent (as % of GDP) of Benin in 1993?
Ensure brevity in your answer.  1.92. What is the difference between the Oil Rent (as % of GDP) in Least developed countries in 1991 and the Oil Rent (as % of GDP) in France in 1993?
Offer a very short reply. 3.16. What is the difference between the Oil Rent (as % of GDP) in Other small states in 1991 and the Oil Rent (as % of GDP) in Benin in 1993?
Ensure brevity in your answer.  7.41. What is the difference between the Oil Rent (as % of GDP) of Other small states in 1991 and the Oil Rent (as % of GDP) of France in 1993?
Ensure brevity in your answer.  8.64. What is the difference between the Oil Rent (as % of GDP) in Benin in 1991 and the Oil Rent (as % of GDP) in France in 1993?
Your response must be concise. 1.16. What is the difference between the Oil Rent (as % of GDP) of Least developed countries in 1992 and the Oil Rent (as % of GDP) of Other small states in 1993?
Provide a short and direct response. -4.05. What is the difference between the Oil Rent (as % of GDP) in Least developed countries in 1992 and the Oil Rent (as % of GDP) in Benin in 1993?
Your answer should be compact. 2.17. What is the difference between the Oil Rent (as % of GDP) in Least developed countries in 1992 and the Oil Rent (as % of GDP) in France in 1993?
Offer a very short reply. 3.4. What is the difference between the Oil Rent (as % of GDP) in Other small states in 1992 and the Oil Rent (as % of GDP) in Benin in 1993?
Provide a succinct answer. 6.39. What is the difference between the Oil Rent (as % of GDP) in Other small states in 1992 and the Oil Rent (as % of GDP) in France in 1993?
Make the answer very short. 7.63. What is the difference between the Oil Rent (as % of GDP) of Benin in 1992 and the Oil Rent (as % of GDP) of France in 1993?
Your answer should be very brief. 1.86. What is the average Oil Rent (as % of GDP) of Least developed countries per year?
Keep it short and to the point. 2.49. What is the average Oil Rent (as % of GDP) of Other small states per year?
Your answer should be compact. 7.43. What is the average Oil Rent (as % of GDP) of Benin per year?
Your response must be concise. 1.66. What is the average Oil Rent (as % of GDP) of France per year?
Offer a terse response. 0.03. In the year 1986, what is the difference between the Oil Rent (as % of GDP) of Least developed countries and Oil Rent (as % of GDP) of Other small states?
Your answer should be very brief. -5.35. In the year 1986, what is the difference between the Oil Rent (as % of GDP) in Least developed countries and Oil Rent (as % of GDP) in Benin?
Your response must be concise. -1.18. In the year 1986, what is the difference between the Oil Rent (as % of GDP) of Least developed countries and Oil Rent (as % of GDP) of France?
Your answer should be very brief. 1.15. In the year 1986, what is the difference between the Oil Rent (as % of GDP) of Other small states and Oil Rent (as % of GDP) of Benin?
Provide a succinct answer. 4.17. In the year 1986, what is the difference between the Oil Rent (as % of GDP) of Other small states and Oil Rent (as % of GDP) of France?
Provide a short and direct response. 6.5. In the year 1986, what is the difference between the Oil Rent (as % of GDP) in Benin and Oil Rent (as % of GDP) in France?
Keep it short and to the point. 2.34. In the year 1987, what is the difference between the Oil Rent (as % of GDP) of Least developed countries and Oil Rent (as % of GDP) of Other small states?
Your response must be concise. -4.85. In the year 1987, what is the difference between the Oil Rent (as % of GDP) in Least developed countries and Oil Rent (as % of GDP) in Benin?
Your answer should be very brief. -0.41. In the year 1987, what is the difference between the Oil Rent (as % of GDP) in Least developed countries and Oil Rent (as % of GDP) in France?
Your answer should be very brief. 1.99. In the year 1987, what is the difference between the Oil Rent (as % of GDP) of Other small states and Oil Rent (as % of GDP) of Benin?
Your response must be concise. 4.44. In the year 1987, what is the difference between the Oil Rent (as % of GDP) of Other small states and Oil Rent (as % of GDP) of France?
Your answer should be very brief. 6.84. In the year 1987, what is the difference between the Oil Rent (as % of GDP) of Benin and Oil Rent (as % of GDP) of France?
Your answer should be very brief. 2.4. In the year 1988, what is the difference between the Oil Rent (as % of GDP) in Least developed countries and Oil Rent (as % of GDP) in Other small states?
Your answer should be very brief. -3.6. In the year 1988, what is the difference between the Oil Rent (as % of GDP) in Least developed countries and Oil Rent (as % of GDP) in Benin?
Ensure brevity in your answer.  0.3. In the year 1988, what is the difference between the Oil Rent (as % of GDP) of Least developed countries and Oil Rent (as % of GDP) of France?
Offer a very short reply. 1.56. In the year 1988, what is the difference between the Oil Rent (as % of GDP) in Other small states and Oil Rent (as % of GDP) in Benin?
Ensure brevity in your answer.  3.89. In the year 1988, what is the difference between the Oil Rent (as % of GDP) of Other small states and Oil Rent (as % of GDP) of France?
Give a very brief answer. 5.15. In the year 1988, what is the difference between the Oil Rent (as % of GDP) in Benin and Oil Rent (as % of GDP) in France?
Your answer should be compact. 1.26. In the year 1989, what is the difference between the Oil Rent (as % of GDP) in Least developed countries and Oil Rent (as % of GDP) in Other small states?
Offer a terse response. -5.08. In the year 1989, what is the difference between the Oil Rent (as % of GDP) of Least developed countries and Oil Rent (as % of GDP) of Benin?
Offer a terse response. 0.59. In the year 1989, what is the difference between the Oil Rent (as % of GDP) of Least developed countries and Oil Rent (as % of GDP) of France?
Provide a succinct answer. 1.96. In the year 1989, what is the difference between the Oil Rent (as % of GDP) in Other small states and Oil Rent (as % of GDP) in Benin?
Your response must be concise. 5.66. In the year 1989, what is the difference between the Oil Rent (as % of GDP) in Other small states and Oil Rent (as % of GDP) in France?
Give a very brief answer. 7.04. In the year 1989, what is the difference between the Oil Rent (as % of GDP) of Benin and Oil Rent (as % of GDP) of France?
Keep it short and to the point. 1.37. In the year 1990, what is the difference between the Oil Rent (as % of GDP) of Least developed countries and Oil Rent (as % of GDP) of Other small states?
Make the answer very short. -6.22. In the year 1990, what is the difference between the Oil Rent (as % of GDP) in Least developed countries and Oil Rent (as % of GDP) in Benin?
Offer a terse response. 2.34. In the year 1990, what is the difference between the Oil Rent (as % of GDP) in Least developed countries and Oil Rent (as % of GDP) in France?
Provide a succinct answer. 3.77. In the year 1990, what is the difference between the Oil Rent (as % of GDP) in Other small states and Oil Rent (as % of GDP) in Benin?
Keep it short and to the point. 8.57. In the year 1990, what is the difference between the Oil Rent (as % of GDP) in Other small states and Oil Rent (as % of GDP) in France?
Provide a succinct answer. 10. In the year 1990, what is the difference between the Oil Rent (as % of GDP) in Benin and Oil Rent (as % of GDP) in France?
Your response must be concise. 1.43. In the year 1991, what is the difference between the Oil Rent (as % of GDP) of Least developed countries and Oil Rent (as % of GDP) of Other small states?
Make the answer very short. -5.48. In the year 1991, what is the difference between the Oil Rent (as % of GDP) in Least developed countries and Oil Rent (as % of GDP) in Benin?
Your answer should be compact. 2. In the year 1991, what is the difference between the Oil Rent (as % of GDP) of Least developed countries and Oil Rent (as % of GDP) of France?
Offer a very short reply. 3.15. In the year 1991, what is the difference between the Oil Rent (as % of GDP) in Other small states and Oil Rent (as % of GDP) in Benin?
Your answer should be very brief. 7.48. In the year 1991, what is the difference between the Oil Rent (as % of GDP) of Other small states and Oil Rent (as % of GDP) of France?
Your answer should be compact. 8.64. In the year 1991, what is the difference between the Oil Rent (as % of GDP) of Benin and Oil Rent (as % of GDP) of France?
Your response must be concise. 1.15. In the year 1992, what is the difference between the Oil Rent (as % of GDP) in Least developed countries and Oil Rent (as % of GDP) in Other small states?
Your answer should be very brief. -4.22. In the year 1992, what is the difference between the Oil Rent (as % of GDP) in Least developed countries and Oil Rent (as % of GDP) in Benin?
Make the answer very short. 1.55. In the year 1992, what is the difference between the Oil Rent (as % of GDP) in Least developed countries and Oil Rent (as % of GDP) in France?
Offer a terse response. 3.4. In the year 1992, what is the difference between the Oil Rent (as % of GDP) of Other small states and Oil Rent (as % of GDP) of Benin?
Give a very brief answer. 5.77. In the year 1992, what is the difference between the Oil Rent (as % of GDP) in Other small states and Oil Rent (as % of GDP) in France?
Ensure brevity in your answer.  7.62. In the year 1992, what is the difference between the Oil Rent (as % of GDP) of Benin and Oil Rent (as % of GDP) of France?
Offer a terse response. 1.85. In the year 1993, what is the difference between the Oil Rent (as % of GDP) of Least developed countries and Oil Rent (as % of GDP) of Other small states?
Provide a succinct answer. -4.74. In the year 1993, what is the difference between the Oil Rent (as % of GDP) in Least developed countries and Oil Rent (as % of GDP) in Benin?
Offer a very short reply. 1.48. In the year 1993, what is the difference between the Oil Rent (as % of GDP) of Least developed countries and Oil Rent (as % of GDP) of France?
Make the answer very short. 2.72. In the year 1993, what is the difference between the Oil Rent (as % of GDP) of Other small states and Oil Rent (as % of GDP) of Benin?
Make the answer very short. 6.22. In the year 1993, what is the difference between the Oil Rent (as % of GDP) of Other small states and Oil Rent (as % of GDP) of France?
Your response must be concise. 7.45. In the year 1993, what is the difference between the Oil Rent (as % of GDP) in Benin and Oil Rent (as % of GDP) in France?
Provide a short and direct response. 1.24. What is the ratio of the Oil Rent (as % of GDP) in Least developed countries in 1986 to that in 1987?
Keep it short and to the point. 0.58. What is the ratio of the Oil Rent (as % of GDP) of Other small states in 1986 to that in 1987?
Keep it short and to the point. 0.95. What is the ratio of the Oil Rent (as % of GDP) of Benin in 1986 to that in 1987?
Provide a short and direct response. 0.97. What is the ratio of the Oil Rent (as % of GDP) in France in 1986 to that in 1987?
Offer a terse response. 0.77. What is the ratio of the Oil Rent (as % of GDP) in Least developed countries in 1986 to that in 1988?
Your answer should be very brief. 0.75. What is the ratio of the Oil Rent (as % of GDP) of Other small states in 1986 to that in 1988?
Provide a succinct answer. 1.26. What is the ratio of the Oil Rent (as % of GDP) of Benin in 1986 to that in 1988?
Your response must be concise. 1.84. What is the ratio of the Oil Rent (as % of GDP) in France in 1986 to that in 1988?
Offer a very short reply. 1.09. What is the ratio of the Oil Rent (as % of GDP) of Least developed countries in 1986 to that in 1989?
Offer a very short reply. 0.59. What is the ratio of the Oil Rent (as % of GDP) in Other small states in 1986 to that in 1989?
Offer a very short reply. 0.92. What is the ratio of the Oil Rent (as % of GDP) in Benin in 1986 to that in 1989?
Your answer should be compact. 1.68. What is the ratio of the Oil Rent (as % of GDP) of France in 1986 to that in 1989?
Ensure brevity in your answer.  0.87. What is the ratio of the Oil Rent (as % of GDP) of Least developed countries in 1986 to that in 1990?
Offer a very short reply. 0.31. What is the ratio of the Oil Rent (as % of GDP) of Other small states in 1986 to that in 1990?
Give a very brief answer. 0.65. What is the ratio of the Oil Rent (as % of GDP) of Benin in 1986 to that in 1990?
Make the answer very short. 1.61. What is the ratio of the Oil Rent (as % of GDP) in France in 1986 to that in 1990?
Offer a terse response. 0.83. What is the ratio of the Oil Rent (as % of GDP) of Least developed countries in 1986 to that in 1991?
Your answer should be compact. 0.37. What is the ratio of the Oil Rent (as % of GDP) of Other small states in 1986 to that in 1991?
Provide a short and direct response. 0.75. What is the ratio of the Oil Rent (as % of GDP) in Benin in 1986 to that in 1991?
Your answer should be compact. 2. What is the ratio of the Oil Rent (as % of GDP) of France in 1986 to that in 1991?
Offer a terse response. 1.06. What is the ratio of the Oil Rent (as % of GDP) in Least developed countries in 1986 to that in 1992?
Keep it short and to the point. 0.34. What is the ratio of the Oil Rent (as % of GDP) in Other small states in 1986 to that in 1992?
Offer a terse response. 0.85. What is the ratio of the Oil Rent (as % of GDP) in Benin in 1986 to that in 1992?
Make the answer very short. 1.26. What is the ratio of the Oil Rent (as % of GDP) of France in 1986 to that in 1992?
Ensure brevity in your answer.  1.26. What is the ratio of the Oil Rent (as % of GDP) of Least developed countries in 1986 to that in 1993?
Give a very brief answer. 0.43. What is the ratio of the Oil Rent (as % of GDP) of Other small states in 1986 to that in 1993?
Ensure brevity in your answer.  0.87. What is the ratio of the Oil Rent (as % of GDP) of Benin in 1986 to that in 1993?
Ensure brevity in your answer.  1.88. What is the ratio of the Oil Rent (as % of GDP) of France in 1986 to that in 1993?
Offer a terse response. 1.42. What is the ratio of the Oil Rent (as % of GDP) of Least developed countries in 1987 to that in 1988?
Your answer should be very brief. 1.28. What is the ratio of the Oil Rent (as % of GDP) of Other small states in 1987 to that in 1988?
Provide a short and direct response. 1.33. What is the ratio of the Oil Rent (as % of GDP) in Benin in 1987 to that in 1988?
Your response must be concise. 1.9. What is the ratio of the Oil Rent (as % of GDP) in France in 1987 to that in 1988?
Provide a succinct answer. 1.41. What is the ratio of the Oil Rent (as % of GDP) of Least developed countries in 1987 to that in 1989?
Give a very brief answer. 1.02. What is the ratio of the Oil Rent (as % of GDP) in Other small states in 1987 to that in 1989?
Provide a short and direct response. 0.97. What is the ratio of the Oil Rent (as % of GDP) of Benin in 1987 to that in 1989?
Offer a terse response. 1.73. What is the ratio of the Oil Rent (as % of GDP) in France in 1987 to that in 1989?
Make the answer very short. 1.13. What is the ratio of the Oil Rent (as % of GDP) of Least developed countries in 1987 to that in 1990?
Provide a succinct answer. 0.53. What is the ratio of the Oil Rent (as % of GDP) in Other small states in 1987 to that in 1990?
Provide a short and direct response. 0.69. What is the ratio of the Oil Rent (as % of GDP) in Benin in 1987 to that in 1990?
Keep it short and to the point. 1.67. What is the ratio of the Oil Rent (as % of GDP) of France in 1987 to that in 1990?
Offer a terse response. 1.08. What is the ratio of the Oil Rent (as % of GDP) of Least developed countries in 1987 to that in 1991?
Offer a terse response. 0.64. What is the ratio of the Oil Rent (as % of GDP) in Other small states in 1987 to that in 1991?
Your response must be concise. 0.79. What is the ratio of the Oil Rent (as % of GDP) of Benin in 1987 to that in 1991?
Provide a short and direct response. 2.06. What is the ratio of the Oil Rent (as % of GDP) in France in 1987 to that in 1991?
Offer a very short reply. 1.38. What is the ratio of the Oil Rent (as % of GDP) of Least developed countries in 1987 to that in 1992?
Provide a short and direct response. 0.59. What is the ratio of the Oil Rent (as % of GDP) of Other small states in 1987 to that in 1992?
Offer a very short reply. 0.9. What is the ratio of the Oil Rent (as % of GDP) in Benin in 1987 to that in 1992?
Provide a succinct answer. 1.3. What is the ratio of the Oil Rent (as % of GDP) of France in 1987 to that in 1992?
Make the answer very short. 1.63. What is the ratio of the Oil Rent (as % of GDP) in Least developed countries in 1987 to that in 1993?
Make the answer very short. 0.74. What is the ratio of the Oil Rent (as % of GDP) of Other small states in 1987 to that in 1993?
Ensure brevity in your answer.  0.92. What is the ratio of the Oil Rent (as % of GDP) of Benin in 1987 to that in 1993?
Keep it short and to the point. 1.94. What is the ratio of the Oil Rent (as % of GDP) of France in 1987 to that in 1993?
Offer a terse response. 1.85. What is the ratio of the Oil Rent (as % of GDP) of Least developed countries in 1988 to that in 1989?
Offer a very short reply. 0.79. What is the ratio of the Oil Rent (as % of GDP) of Other small states in 1988 to that in 1989?
Your answer should be compact. 0.73. What is the ratio of the Oil Rent (as % of GDP) of Benin in 1988 to that in 1989?
Your response must be concise. 0.91. What is the ratio of the Oil Rent (as % of GDP) in France in 1988 to that in 1989?
Give a very brief answer. 0.8. What is the ratio of the Oil Rent (as % of GDP) of Least developed countries in 1988 to that in 1990?
Keep it short and to the point. 0.42. What is the ratio of the Oil Rent (as % of GDP) of Other small states in 1988 to that in 1990?
Make the answer very short. 0.52. What is the ratio of the Oil Rent (as % of GDP) in Benin in 1988 to that in 1990?
Your response must be concise. 0.88. What is the ratio of the Oil Rent (as % of GDP) in France in 1988 to that in 1990?
Your response must be concise. 0.77. What is the ratio of the Oil Rent (as % of GDP) of Least developed countries in 1988 to that in 1991?
Keep it short and to the point. 0.5. What is the ratio of the Oil Rent (as % of GDP) in Other small states in 1988 to that in 1991?
Your answer should be compact. 0.6. What is the ratio of the Oil Rent (as % of GDP) in Benin in 1988 to that in 1991?
Your response must be concise. 1.09. What is the ratio of the Oil Rent (as % of GDP) in France in 1988 to that in 1991?
Provide a succinct answer. 0.97. What is the ratio of the Oil Rent (as % of GDP) in Least developed countries in 1988 to that in 1992?
Ensure brevity in your answer.  0.46. What is the ratio of the Oil Rent (as % of GDP) in Other small states in 1988 to that in 1992?
Keep it short and to the point. 0.68. What is the ratio of the Oil Rent (as % of GDP) of Benin in 1988 to that in 1992?
Provide a short and direct response. 0.69. What is the ratio of the Oil Rent (as % of GDP) of France in 1988 to that in 1992?
Keep it short and to the point. 1.15. What is the ratio of the Oil Rent (as % of GDP) of Least developed countries in 1988 to that in 1993?
Make the answer very short. 0.58. What is the ratio of the Oil Rent (as % of GDP) in Other small states in 1988 to that in 1993?
Your response must be concise. 0.69. What is the ratio of the Oil Rent (as % of GDP) in Benin in 1988 to that in 1993?
Give a very brief answer. 1.02. What is the ratio of the Oil Rent (as % of GDP) of France in 1988 to that in 1993?
Offer a terse response. 1.31. What is the ratio of the Oil Rent (as % of GDP) in Least developed countries in 1989 to that in 1990?
Offer a very short reply. 0.52. What is the ratio of the Oil Rent (as % of GDP) of Other small states in 1989 to that in 1990?
Ensure brevity in your answer.  0.7. What is the ratio of the Oil Rent (as % of GDP) of Benin in 1989 to that in 1990?
Make the answer very short. 0.96. What is the ratio of the Oil Rent (as % of GDP) in France in 1989 to that in 1990?
Offer a terse response. 0.96. What is the ratio of the Oil Rent (as % of GDP) in Least developed countries in 1989 to that in 1991?
Give a very brief answer. 0.63. What is the ratio of the Oil Rent (as % of GDP) of Other small states in 1989 to that in 1991?
Ensure brevity in your answer.  0.82. What is the ratio of the Oil Rent (as % of GDP) in Benin in 1989 to that in 1991?
Make the answer very short. 1.19. What is the ratio of the Oil Rent (as % of GDP) of France in 1989 to that in 1991?
Offer a very short reply. 1.21. What is the ratio of the Oil Rent (as % of GDP) of Least developed countries in 1989 to that in 1992?
Ensure brevity in your answer.  0.58. What is the ratio of the Oil Rent (as % of GDP) in Other small states in 1989 to that in 1992?
Make the answer very short. 0.92. What is the ratio of the Oil Rent (as % of GDP) of Benin in 1989 to that in 1992?
Provide a short and direct response. 0.75. What is the ratio of the Oil Rent (as % of GDP) in France in 1989 to that in 1992?
Offer a very short reply. 1.44. What is the ratio of the Oil Rent (as % of GDP) in Least developed countries in 1989 to that in 1993?
Your response must be concise. 0.73. What is the ratio of the Oil Rent (as % of GDP) in Other small states in 1989 to that in 1993?
Your answer should be compact. 0.95. What is the ratio of the Oil Rent (as % of GDP) of Benin in 1989 to that in 1993?
Your answer should be compact. 1.12. What is the ratio of the Oil Rent (as % of GDP) of France in 1989 to that in 1993?
Your answer should be very brief. 1.63. What is the ratio of the Oil Rent (as % of GDP) in Least developed countries in 1990 to that in 1991?
Provide a short and direct response. 1.2. What is the ratio of the Oil Rent (as % of GDP) of Other small states in 1990 to that in 1991?
Offer a terse response. 1.16. What is the ratio of the Oil Rent (as % of GDP) in Benin in 1990 to that in 1991?
Offer a very short reply. 1.24. What is the ratio of the Oil Rent (as % of GDP) of France in 1990 to that in 1991?
Your answer should be compact. 1.27. What is the ratio of the Oil Rent (as % of GDP) in Least developed countries in 1990 to that in 1992?
Offer a very short reply. 1.11. What is the ratio of the Oil Rent (as % of GDP) of Other small states in 1990 to that in 1992?
Ensure brevity in your answer.  1.31. What is the ratio of the Oil Rent (as % of GDP) in Benin in 1990 to that in 1992?
Ensure brevity in your answer.  0.78. What is the ratio of the Oil Rent (as % of GDP) in France in 1990 to that in 1992?
Keep it short and to the point. 1.51. What is the ratio of the Oil Rent (as % of GDP) in Least developed countries in 1990 to that in 1993?
Offer a very short reply. 1.39. What is the ratio of the Oil Rent (as % of GDP) in Other small states in 1990 to that in 1993?
Make the answer very short. 1.34. What is the ratio of the Oil Rent (as % of GDP) of Benin in 1990 to that in 1993?
Make the answer very short. 1.16. What is the ratio of the Oil Rent (as % of GDP) in France in 1990 to that in 1993?
Your answer should be very brief. 1.7. What is the ratio of the Oil Rent (as % of GDP) of Least developed countries in 1991 to that in 1992?
Offer a very short reply. 0.93. What is the ratio of the Oil Rent (as % of GDP) in Other small states in 1991 to that in 1992?
Offer a very short reply. 1.13. What is the ratio of the Oil Rent (as % of GDP) in Benin in 1991 to that in 1992?
Offer a very short reply. 0.63. What is the ratio of the Oil Rent (as % of GDP) in France in 1991 to that in 1992?
Your answer should be compact. 1.18. What is the ratio of the Oil Rent (as % of GDP) in Least developed countries in 1991 to that in 1993?
Give a very brief answer. 1.16. What is the ratio of the Oil Rent (as % of GDP) in Other small states in 1991 to that in 1993?
Make the answer very short. 1.16. What is the ratio of the Oil Rent (as % of GDP) in Benin in 1991 to that in 1993?
Make the answer very short. 0.94. What is the ratio of the Oil Rent (as % of GDP) of France in 1991 to that in 1993?
Your answer should be compact. 1.34. What is the ratio of the Oil Rent (as % of GDP) in Least developed countries in 1992 to that in 1993?
Offer a terse response. 1.25. What is the ratio of the Oil Rent (as % of GDP) in Benin in 1992 to that in 1993?
Give a very brief answer. 1.49. What is the ratio of the Oil Rent (as % of GDP) in France in 1992 to that in 1993?
Your response must be concise. 1.13. What is the difference between the highest and the second highest Oil Rent (as % of GDP) of Least developed countries?
Your answer should be very brief. 0.38. What is the difference between the highest and the second highest Oil Rent (as % of GDP) of Other small states?
Make the answer very short. 1.37. What is the difference between the highest and the second highest Oil Rent (as % of GDP) in Benin?
Offer a very short reply. 0.07. What is the difference between the highest and the second highest Oil Rent (as % of GDP) of France?
Your answer should be compact. 0. What is the difference between the highest and the lowest Oil Rent (as % of GDP) of Least developed countries?
Provide a succinct answer. 2.63. What is the difference between the highest and the lowest Oil Rent (as % of GDP) in Other small states?
Offer a very short reply. 4.85. What is the difference between the highest and the lowest Oil Rent (as % of GDP) of Benin?
Make the answer very short. 1.26. What is the difference between the highest and the lowest Oil Rent (as % of GDP) in France?
Your answer should be compact. 0.02. 